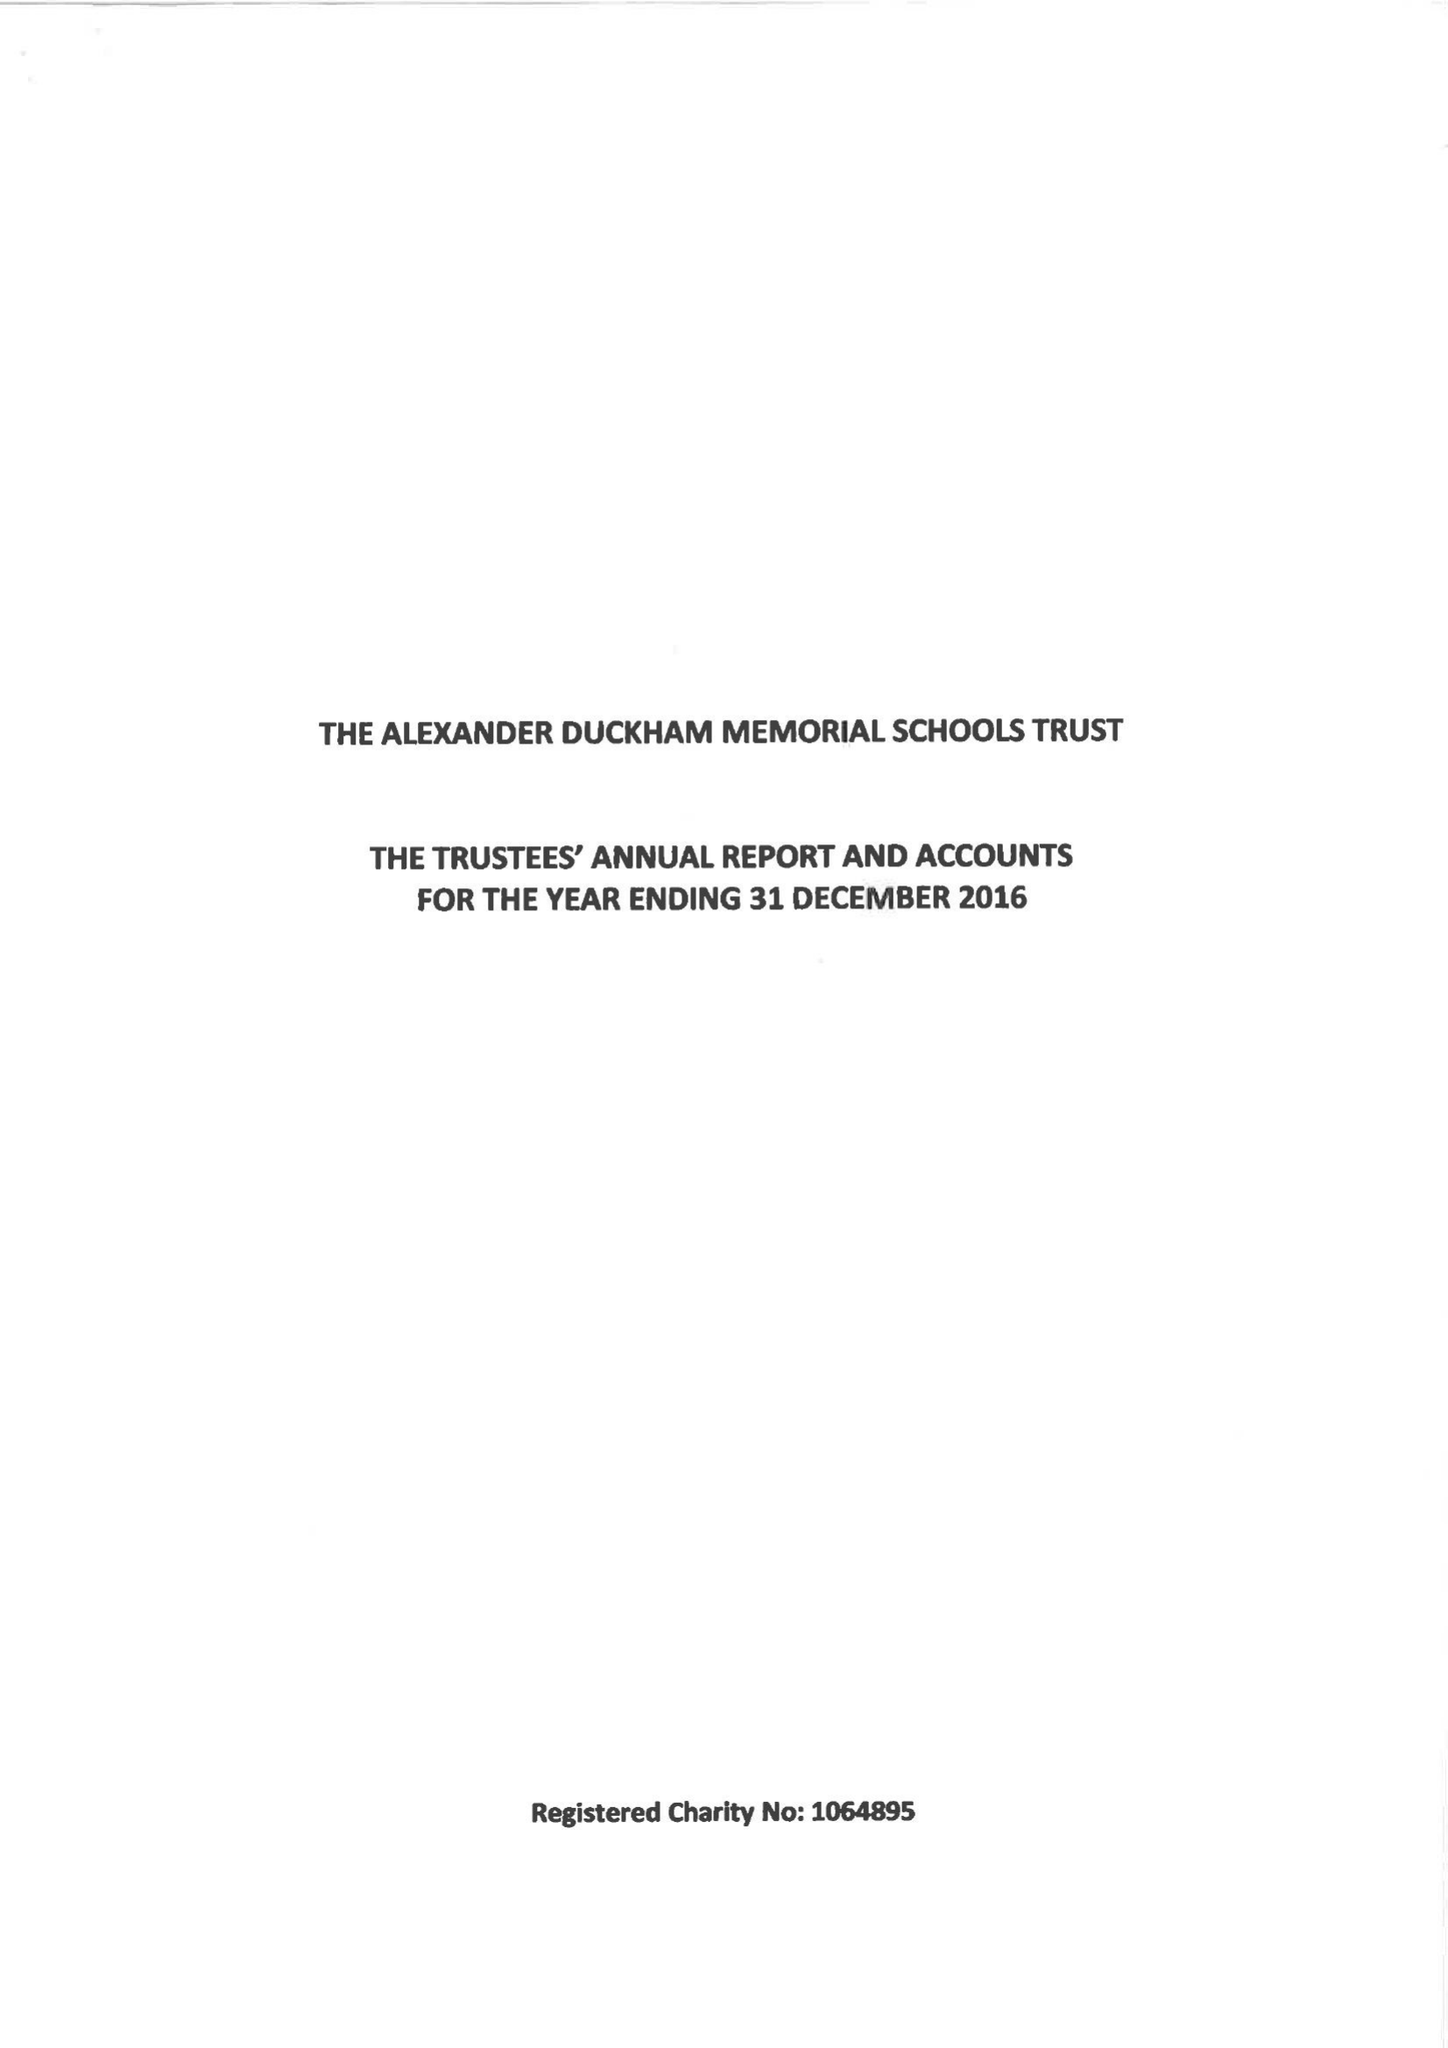What is the value for the spending_annually_in_british_pounds?
Answer the question using a single word or phrase. 119488.00 